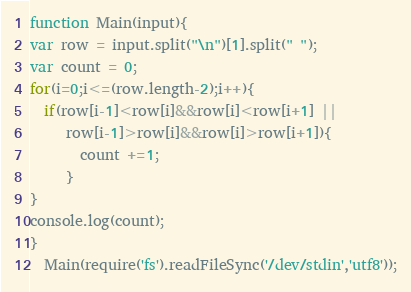<code> <loc_0><loc_0><loc_500><loc_500><_JavaScript_>function Main(input){
var row = input.split("\n")[1].split(" ");
var count = 0;
for(i=0;i<=(row.length-2);i++){
  if(row[i-1]<row[i]&&row[i]<row[i+1] ||
     row[i-1]>row[i]&&row[i]>row[i+1]){
       count +=1;
     }
}
console.log(count);
}
  Main(require('fs').readFileSync('/dev/stdin','utf8'));</code> 